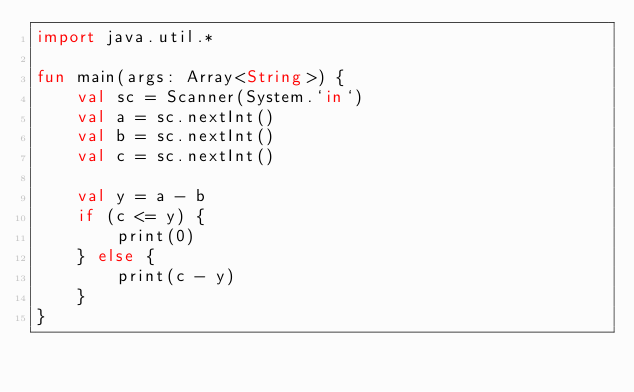<code> <loc_0><loc_0><loc_500><loc_500><_Kotlin_>import java.util.*

fun main(args: Array<String>) {
    val sc = Scanner(System.`in`)
    val a = sc.nextInt()
    val b = sc.nextInt()
    val c = sc.nextInt()

    val y = a - b
    if (c <= y) {
        print(0)
    } else {
        print(c - y)
    }
}
</code> 